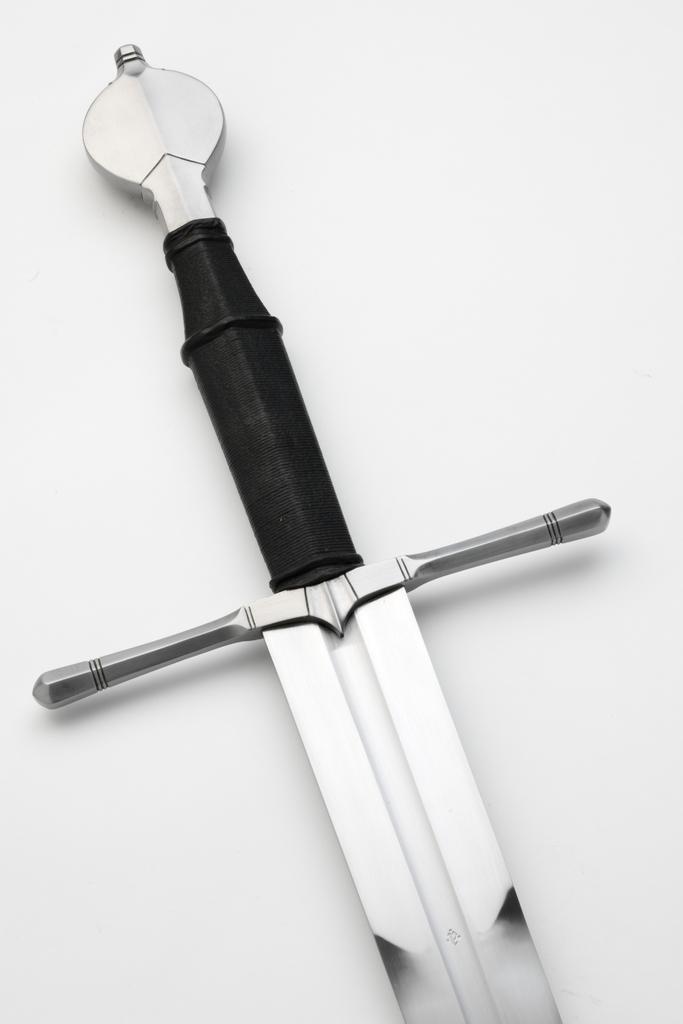How would you summarize this image in a sentence or two? In this image we can see a sword placed on the white color surface. 